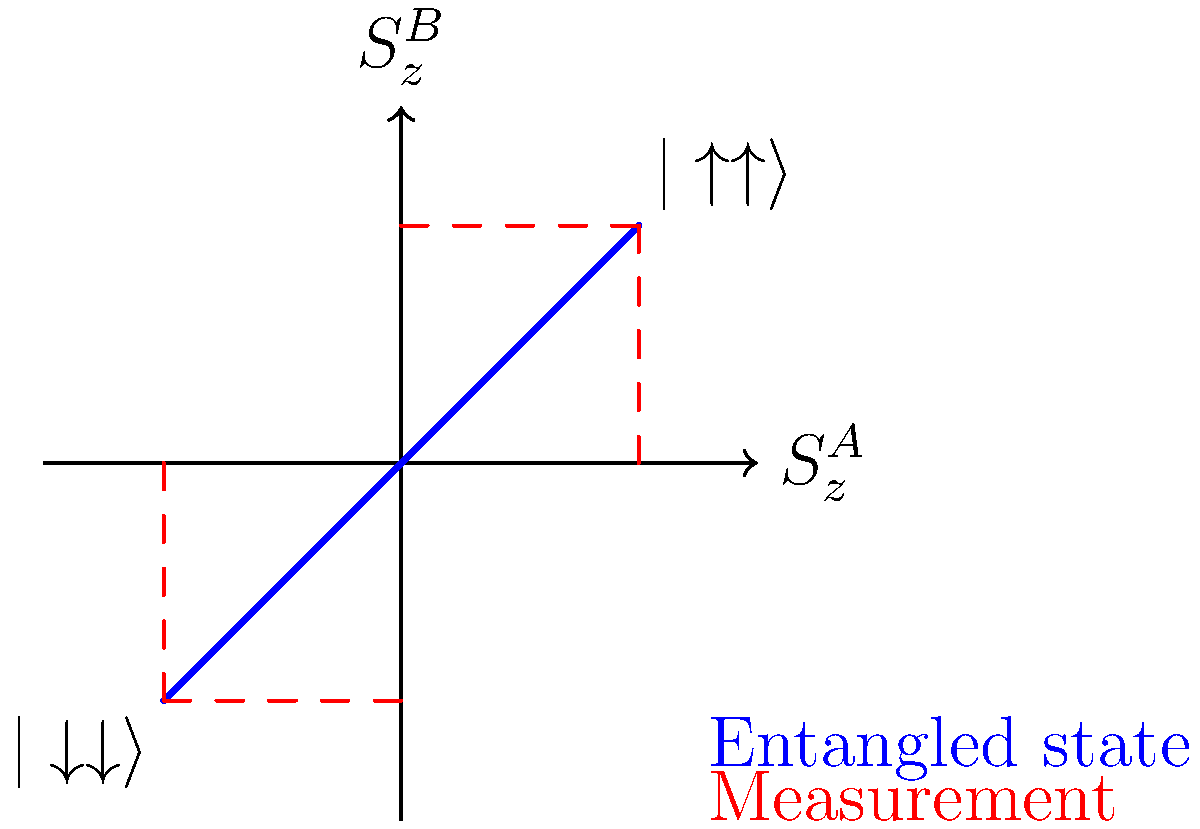In the context of quantum entanglement, the diagram represents the spin correlations between two particles, A and B. What fundamental quantum mechanical principle does this visual representation illustrate, and how might it inspire a plot device in a science fiction novel? 1. The diagram shows the correlation between the z-component of spin ($S_z$) for two entangled particles, A and B.

2. The blue line represents the entangled state, connecting the points $(1,1)$ and $(-1,-1)$, which correspond to the $|\uparrow\uparrow\rangle$ and $|\downarrow\downarrow\rangle$ states, respectively.

3. This perfect correlation illustrates the principle of quantum entanglement, where the measurement outcome of one particle instantly determines the state of the other, regardless of their separation in space.

4. The dashed red lines represent potential measurements. When a measurement is made on particle A, it projects the system onto one of the axes, immediately determining the state of particle B.

5. This "spooky action at a distance," as Einstein called it, demonstrates the non-local nature of quantum mechanics and the collapse of the wave function upon measurement.

6. The principle illustrated is the EPR paradox (Einstein-Podolsky-Rosen paradox), which challenges local realism in quantum mechanics.

7. In a science fiction context, this could inspire plot devices such as:
   a) Instantaneous communication across vast distances
   b) Quantum teleportation systems
   c) Entanglement-based encryption for unbreakable interstellar communications
   d) Parallel universe detectors based on manipulating entangled particles

8. The key principle to emphasize is that entanglement allows for correlations that seem to violate classical intuitions about locality and causality, opening up numerous speculative possibilities for science fiction storytelling.
Answer: EPR paradox; enables instant, distance-independent correlations for potential FTL communication or interdimensional plots. 